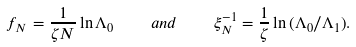Convert formula to latex. <formula><loc_0><loc_0><loc_500><loc_500>f _ { N } = \frac { 1 } { \zeta N } \ln { \Lambda _ { 0 } } \quad a n d \quad \xi _ { N } ^ { - 1 } = \frac { 1 } { \zeta } \ln { ( \Lambda _ { 0 } / \Lambda _ { 1 } ) } .</formula> 